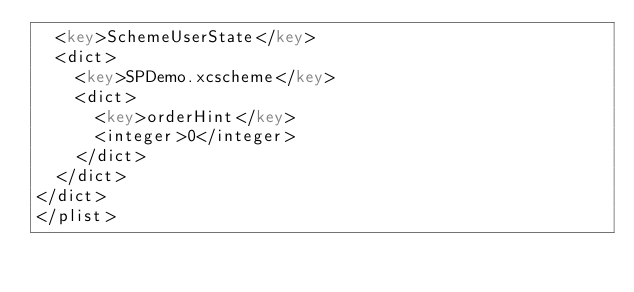Convert code to text. <code><loc_0><loc_0><loc_500><loc_500><_XML_>	<key>SchemeUserState</key>
	<dict>
		<key>SPDemo.xcscheme</key>
		<dict>
			<key>orderHint</key>
			<integer>0</integer>
		</dict>
	</dict>
</dict>
</plist>
</code> 